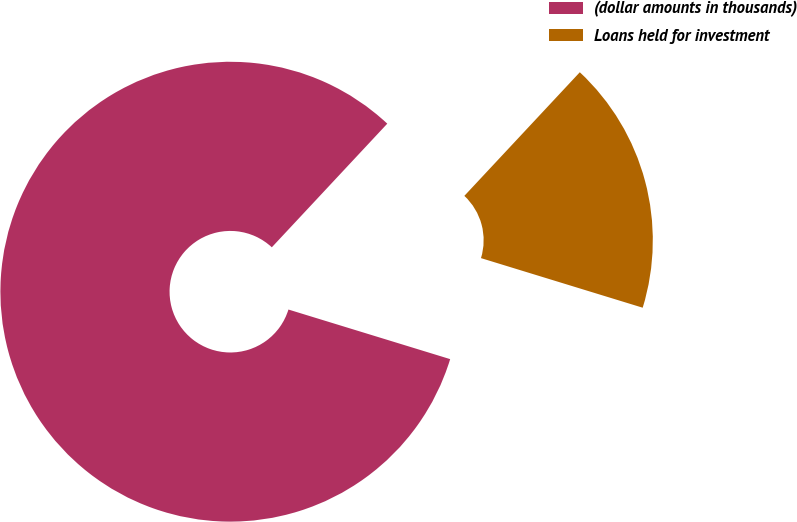Convert chart to OTSL. <chart><loc_0><loc_0><loc_500><loc_500><pie_chart><fcel>(dollar amounts in thousands)<fcel>Loans held for investment<nl><fcel>82.22%<fcel>17.78%<nl></chart> 